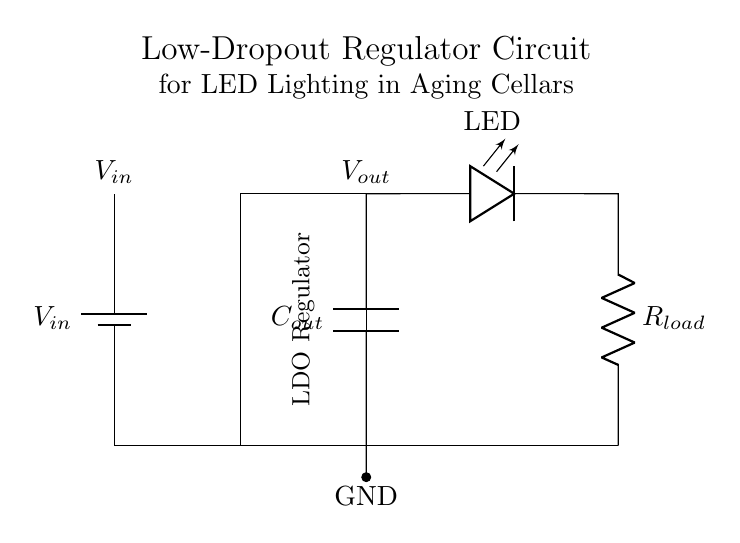What is the input component? The circuit diagram shows a battery labeled as V_in, which is the source of input voltage.
Answer: Battery What type of regulator is used? The diagram indicates that a Low-Dropout Regulator is present, shown by the label within the box on the circuit.
Answer: LDO Regulator What is the purpose of the capacitor in the circuit? The capacitor, labeled as C_out, helps to stabilize the output voltage and reduce voltage fluctuations at the load.
Answer: Stabilization What is connected to the output of the LDO regulator? The output of the LDO is connected to an LED and a load resistor in series, which indicates that the regulator powers the light source.
Answer: LED and load resistor How many components are there in series after the regulator? Post-regulator, the circuit has two components (LED and load resistor) connected in series to the output voltage.
Answer: Two What is the significance of the ground labeled in the circuit? The ground (GND) provides a common reference point for voltage measurements and ensures a return path for current.
Answer: Common reference point What would happen if the input voltage is too low for the LDO? If the input voltage is too low, the LDO may not be able to maintain a stable output voltage, potentially leading to insufficient power for the LED.
Answer: Insufficient power 